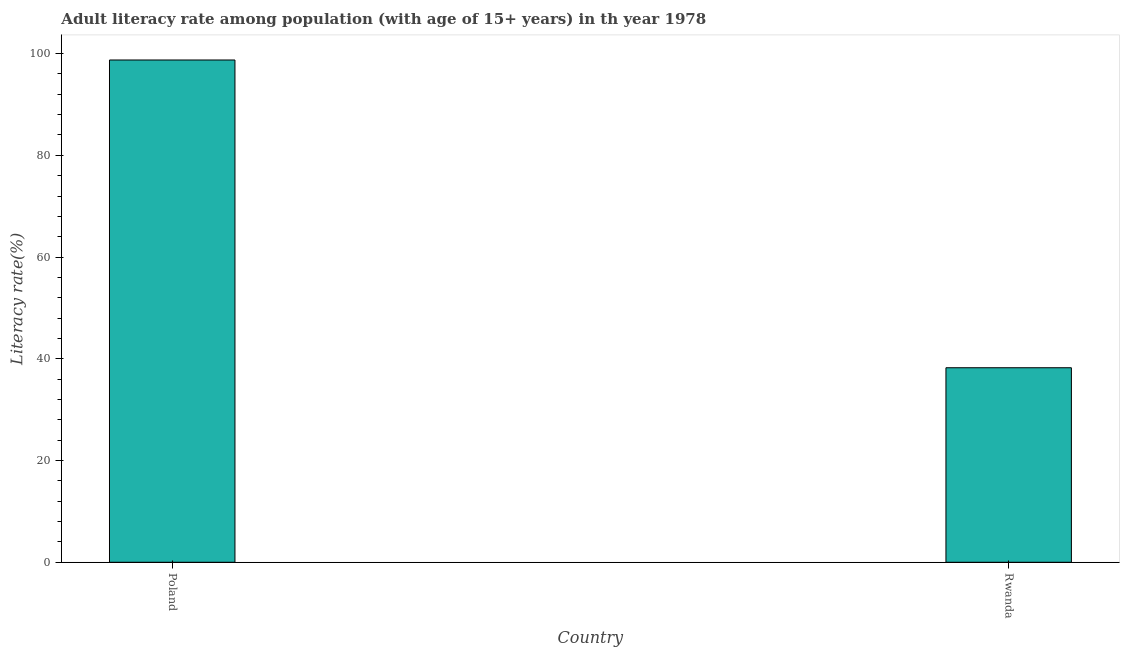Does the graph contain any zero values?
Offer a terse response. No. Does the graph contain grids?
Keep it short and to the point. No. What is the title of the graph?
Keep it short and to the point. Adult literacy rate among population (with age of 15+ years) in th year 1978. What is the label or title of the X-axis?
Your answer should be very brief. Country. What is the label or title of the Y-axis?
Make the answer very short. Literacy rate(%). What is the adult literacy rate in Rwanda?
Offer a very short reply. 38.24. Across all countries, what is the maximum adult literacy rate?
Ensure brevity in your answer.  98.74. Across all countries, what is the minimum adult literacy rate?
Your answer should be very brief. 38.24. In which country was the adult literacy rate minimum?
Keep it short and to the point. Rwanda. What is the sum of the adult literacy rate?
Your response must be concise. 136.99. What is the difference between the adult literacy rate in Poland and Rwanda?
Provide a short and direct response. 60.5. What is the average adult literacy rate per country?
Your answer should be very brief. 68.49. What is the median adult literacy rate?
Offer a very short reply. 68.49. In how many countries, is the adult literacy rate greater than 88 %?
Give a very brief answer. 1. What is the ratio of the adult literacy rate in Poland to that in Rwanda?
Your answer should be compact. 2.58. Is the adult literacy rate in Poland less than that in Rwanda?
Keep it short and to the point. No. How many bars are there?
Offer a very short reply. 2. Are all the bars in the graph horizontal?
Ensure brevity in your answer.  No. How many countries are there in the graph?
Your answer should be compact. 2. Are the values on the major ticks of Y-axis written in scientific E-notation?
Ensure brevity in your answer.  No. What is the Literacy rate(%) of Poland?
Your response must be concise. 98.74. What is the Literacy rate(%) of Rwanda?
Your answer should be compact. 38.24. What is the difference between the Literacy rate(%) in Poland and Rwanda?
Your answer should be very brief. 60.5. What is the ratio of the Literacy rate(%) in Poland to that in Rwanda?
Your answer should be compact. 2.58. 